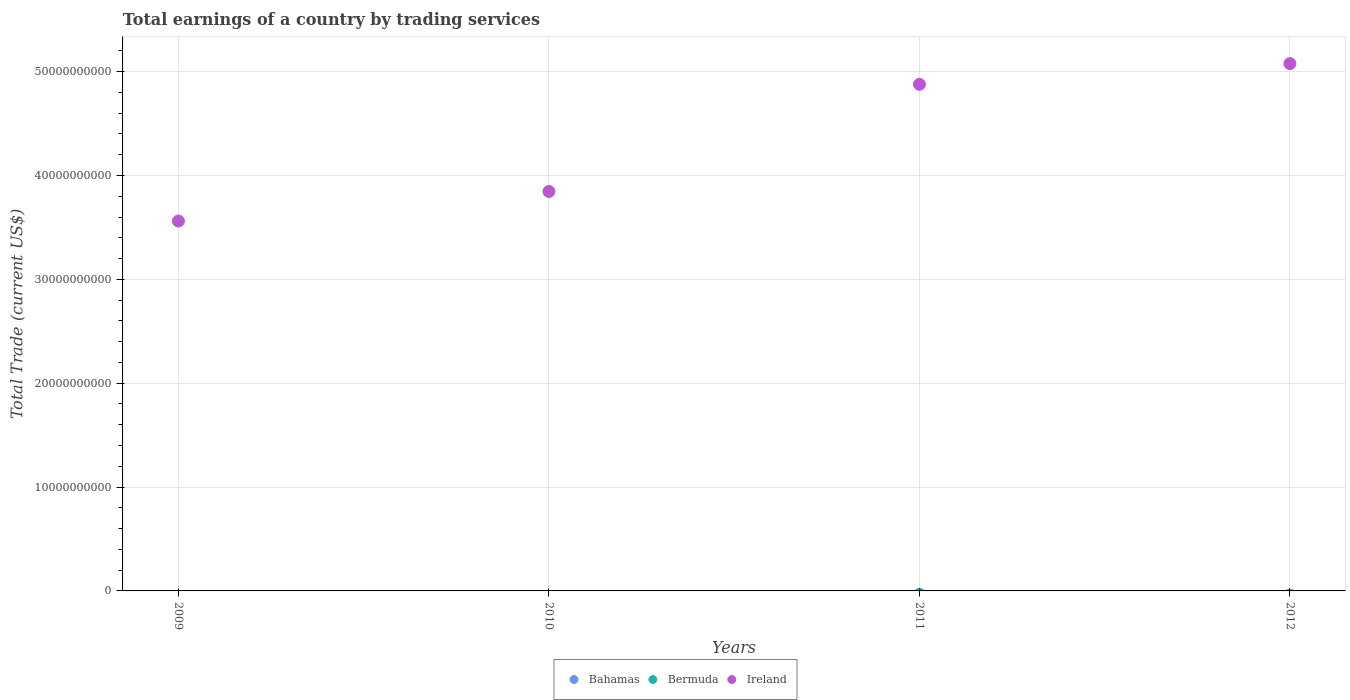Is the number of dotlines equal to the number of legend labels?
Ensure brevity in your answer.  No. What is the total earnings in Ireland in 2010?
Provide a short and direct response. 3.85e+1. Across all years, what is the minimum total earnings in Bahamas?
Keep it short and to the point. 0. What is the total total earnings in Ireland in the graph?
Ensure brevity in your answer.  1.74e+11. What is the difference between the total earnings in Ireland in 2011 and that in 2012?
Provide a short and direct response. -2.00e+09. What is the difference between the total earnings in Bahamas in 2012 and the total earnings in Ireland in 2009?
Your answer should be very brief. -3.56e+1. What is the average total earnings in Bahamas per year?
Ensure brevity in your answer.  0. Is the total earnings in Ireland in 2009 less than that in 2012?
Your answer should be compact. Yes. What is the difference between the highest and the second highest total earnings in Ireland?
Your answer should be compact. 2.00e+09. What is the difference between the highest and the lowest total earnings in Ireland?
Keep it short and to the point. 1.52e+1. In how many years, is the total earnings in Ireland greater than the average total earnings in Ireland taken over all years?
Your answer should be very brief. 2. Is it the case that in every year, the sum of the total earnings in Bermuda and total earnings in Bahamas  is greater than the total earnings in Ireland?
Ensure brevity in your answer.  No. Is the total earnings in Bahamas strictly less than the total earnings in Ireland over the years?
Offer a very short reply. Yes. How many years are there in the graph?
Provide a short and direct response. 4. Where does the legend appear in the graph?
Your answer should be very brief. Bottom center. What is the title of the graph?
Offer a very short reply. Total earnings of a country by trading services. Does "West Bank and Gaza" appear as one of the legend labels in the graph?
Provide a succinct answer. No. What is the label or title of the X-axis?
Offer a very short reply. Years. What is the label or title of the Y-axis?
Your response must be concise. Total Trade (current US$). What is the Total Trade (current US$) of Ireland in 2009?
Provide a short and direct response. 3.56e+1. What is the Total Trade (current US$) in Bahamas in 2010?
Offer a very short reply. 0. What is the Total Trade (current US$) in Bermuda in 2010?
Ensure brevity in your answer.  0. What is the Total Trade (current US$) of Ireland in 2010?
Offer a terse response. 3.85e+1. What is the Total Trade (current US$) of Bahamas in 2011?
Keep it short and to the point. 0. What is the Total Trade (current US$) of Bermuda in 2011?
Offer a terse response. 0. What is the Total Trade (current US$) of Ireland in 2011?
Your response must be concise. 4.88e+1. What is the Total Trade (current US$) of Ireland in 2012?
Your answer should be very brief. 5.08e+1. Across all years, what is the maximum Total Trade (current US$) of Ireland?
Your answer should be very brief. 5.08e+1. Across all years, what is the minimum Total Trade (current US$) of Ireland?
Offer a terse response. 3.56e+1. What is the total Total Trade (current US$) of Ireland in the graph?
Offer a very short reply. 1.74e+11. What is the difference between the Total Trade (current US$) in Ireland in 2009 and that in 2010?
Ensure brevity in your answer.  -2.84e+09. What is the difference between the Total Trade (current US$) in Ireland in 2009 and that in 2011?
Keep it short and to the point. -1.32e+1. What is the difference between the Total Trade (current US$) in Ireland in 2009 and that in 2012?
Keep it short and to the point. -1.52e+1. What is the difference between the Total Trade (current US$) of Ireland in 2010 and that in 2011?
Make the answer very short. -1.03e+1. What is the difference between the Total Trade (current US$) of Ireland in 2010 and that in 2012?
Ensure brevity in your answer.  -1.23e+1. What is the difference between the Total Trade (current US$) in Ireland in 2011 and that in 2012?
Provide a short and direct response. -2.00e+09. What is the average Total Trade (current US$) of Ireland per year?
Your answer should be compact. 4.34e+1. What is the ratio of the Total Trade (current US$) of Ireland in 2009 to that in 2010?
Keep it short and to the point. 0.93. What is the ratio of the Total Trade (current US$) in Ireland in 2009 to that in 2011?
Your response must be concise. 0.73. What is the ratio of the Total Trade (current US$) of Ireland in 2009 to that in 2012?
Provide a short and direct response. 0.7. What is the ratio of the Total Trade (current US$) in Ireland in 2010 to that in 2011?
Ensure brevity in your answer.  0.79. What is the ratio of the Total Trade (current US$) in Ireland in 2010 to that in 2012?
Ensure brevity in your answer.  0.76. What is the ratio of the Total Trade (current US$) of Ireland in 2011 to that in 2012?
Make the answer very short. 0.96. What is the difference between the highest and the second highest Total Trade (current US$) in Ireland?
Offer a terse response. 2.00e+09. What is the difference between the highest and the lowest Total Trade (current US$) in Ireland?
Offer a terse response. 1.52e+1. 